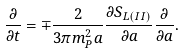<formula> <loc_0><loc_0><loc_500><loc_500>\frac { \partial } { \partial t } = \mp \frac { 2 } { 3 \pi m _ { P } ^ { 2 } a } \frac { \partial S _ { L ( I I ) } } { \partial a } \frac { \partial } { \partial a } .</formula> 